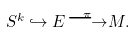<formula> <loc_0><loc_0><loc_500><loc_500>S ^ { k } \hookrightarrow E { \stackrel { \pi } { \longrightarrow } } M .</formula> 